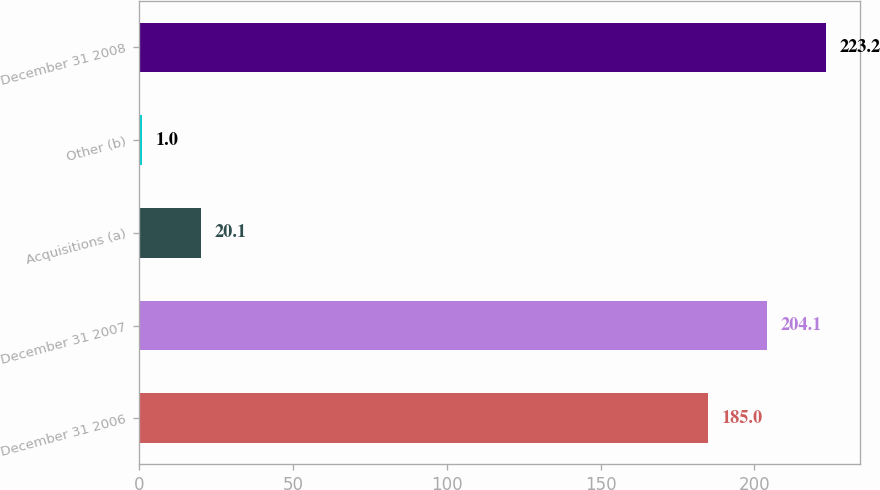Convert chart to OTSL. <chart><loc_0><loc_0><loc_500><loc_500><bar_chart><fcel>December 31 2006<fcel>December 31 2007<fcel>Acquisitions (a)<fcel>Other (b)<fcel>December 31 2008<nl><fcel>185<fcel>204.1<fcel>20.1<fcel>1<fcel>223.2<nl></chart> 